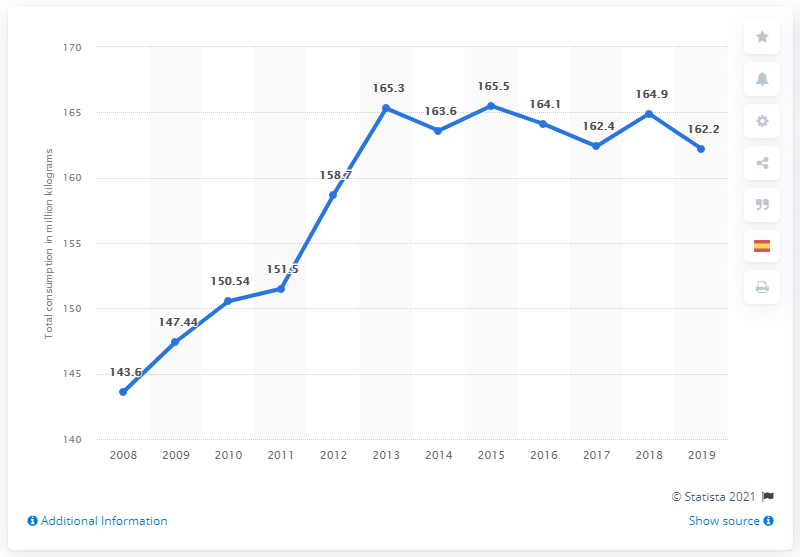Draw attention to some important aspects in this diagram. In 2019, Spain's consumption of chocolate was 162.2 metric tons. In 2013, Spain consumed a significant amount of chocolate, with a total of 164.9 kilograms. 